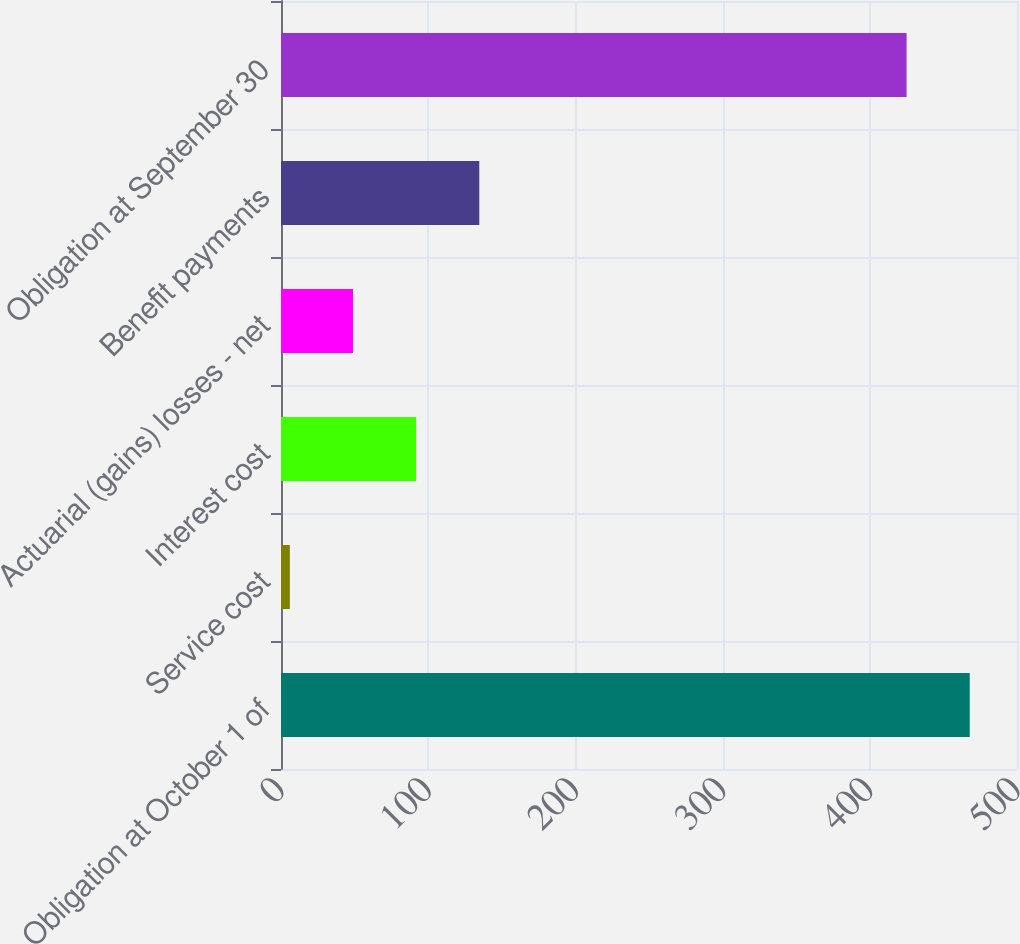Convert chart. <chart><loc_0><loc_0><loc_500><loc_500><bar_chart><fcel>Obligation at October 1 of<fcel>Service cost<fcel>Interest cost<fcel>Actuarial (gains) losses - net<fcel>Benefit payments<fcel>Obligation at September 30<nl><fcel>467.9<fcel>6<fcel>91.8<fcel>48.9<fcel>134.7<fcel>425<nl></chart> 